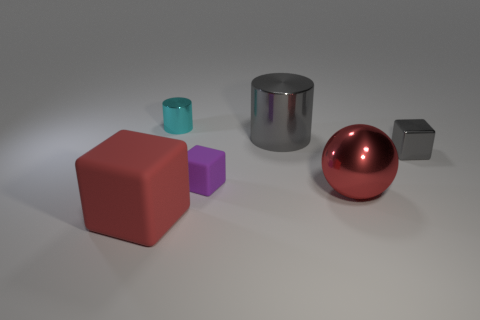Is the large shiny cylinder the same color as the tiny shiny block?
Provide a succinct answer. Yes. There is a purple object that is in front of the metal object behind the gray metal cylinder; what size is it?
Offer a very short reply. Small. Are there an equal number of big cubes behind the big red shiny ball and purple matte cubes in front of the tiny purple rubber cube?
Provide a succinct answer. Yes. There is another object that is the same shape as the big gray object; what is its color?
Make the answer very short. Cyan. How many small objects are the same color as the big metallic cylinder?
Keep it short and to the point. 1. Does the large thing behind the red metal object have the same shape as the cyan shiny object?
Make the answer very short. Yes. What color is the object that is made of the same material as the large cube?
Your response must be concise. Purple. What is the color of the rubber block that is the same size as the cyan metal cylinder?
Your response must be concise. Purple. Is the number of big objects right of the cyan cylinder greater than the number of big things that are behind the large block?
Your answer should be very brief. No. What is the material of the thing that is on the left side of the big cylinder and behind the small purple thing?
Your answer should be very brief. Metal. 